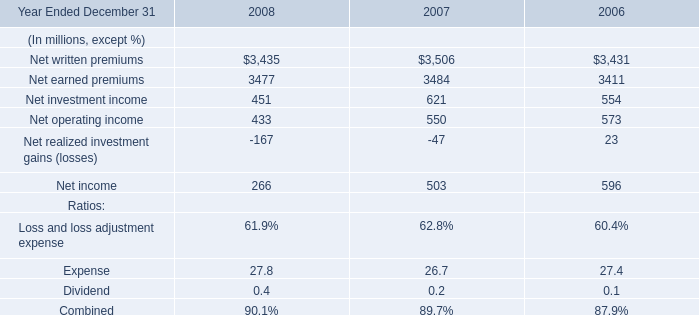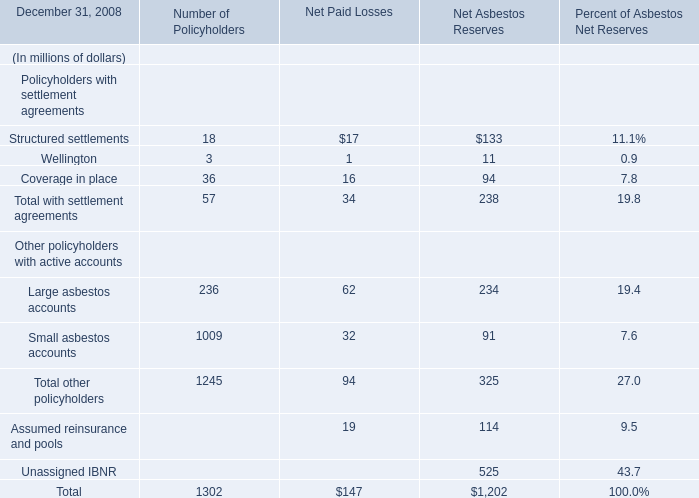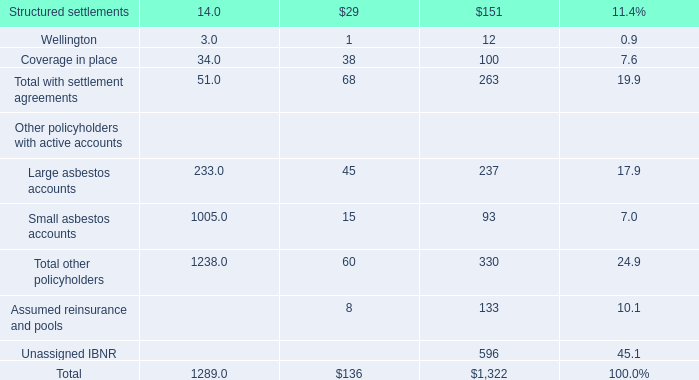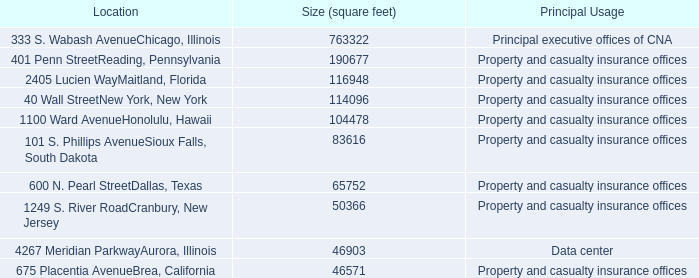what percent of the illinois properties relate to data centers? 
Computations: (46903 / (46903 + 763322))
Answer: 0.05789. 